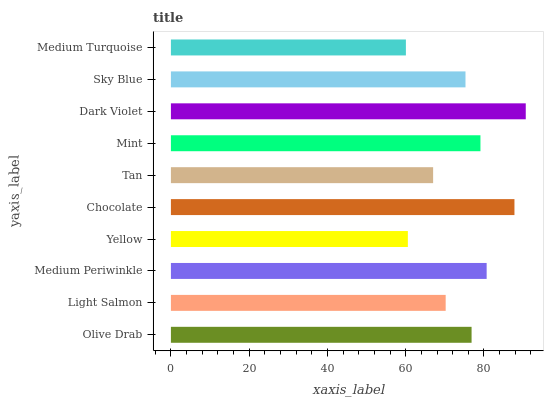Is Medium Turquoise the minimum?
Answer yes or no. Yes. Is Dark Violet the maximum?
Answer yes or no. Yes. Is Light Salmon the minimum?
Answer yes or no. No. Is Light Salmon the maximum?
Answer yes or no. No. Is Olive Drab greater than Light Salmon?
Answer yes or no. Yes. Is Light Salmon less than Olive Drab?
Answer yes or no. Yes. Is Light Salmon greater than Olive Drab?
Answer yes or no. No. Is Olive Drab less than Light Salmon?
Answer yes or no. No. Is Olive Drab the high median?
Answer yes or no. Yes. Is Sky Blue the low median?
Answer yes or no. Yes. Is Chocolate the high median?
Answer yes or no. No. Is Olive Drab the low median?
Answer yes or no. No. 